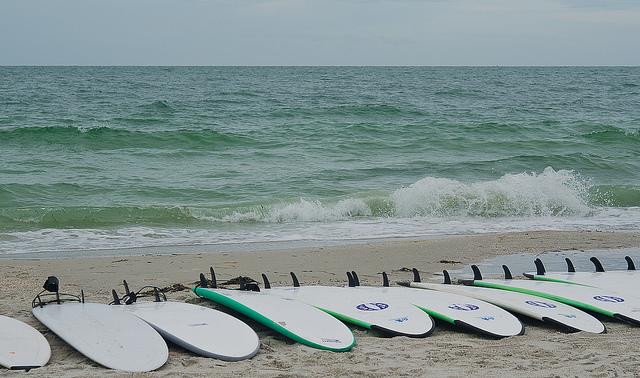What is lined up on the beach?
Quick response, please. Surfboards. What are the fins on the bottom of the surfboard for?
Keep it brief. Balance. How many people are in the water?
Keep it brief. 0. Is the sky clear?
Short answer required. No. Can you surf here?
Write a very short answer. Yes. What color is the water?
Be succinct. Green. 